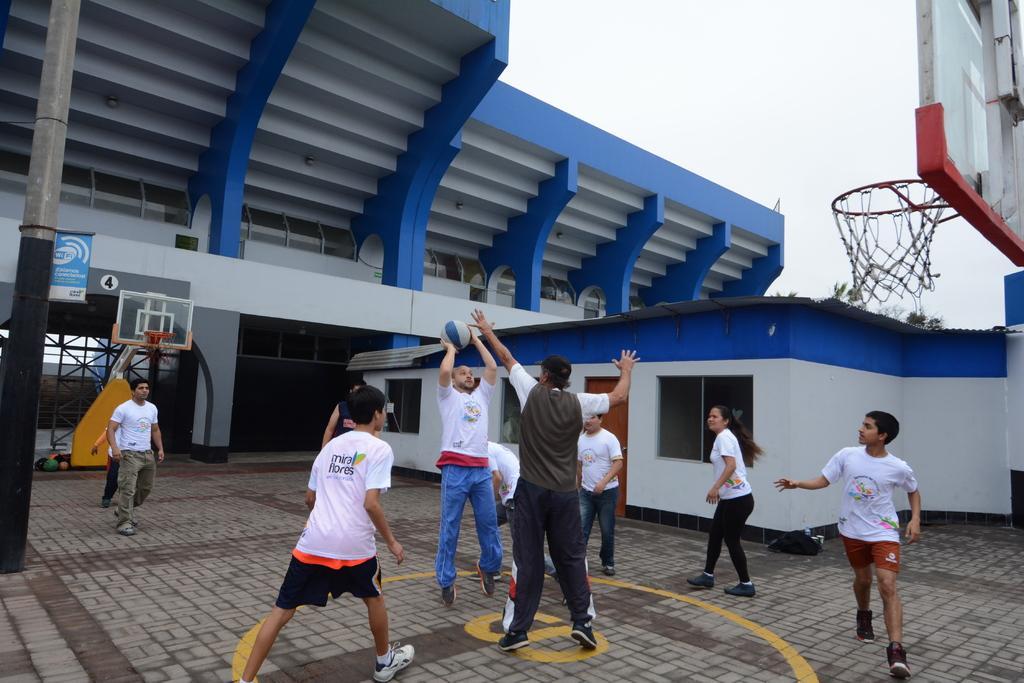Describe this image in one or two sentences. In this picture we can see group of people, they are playing game, and we can see a man, he is holding a ball, in the background we can find few buildings, a pole, sign board and net. 